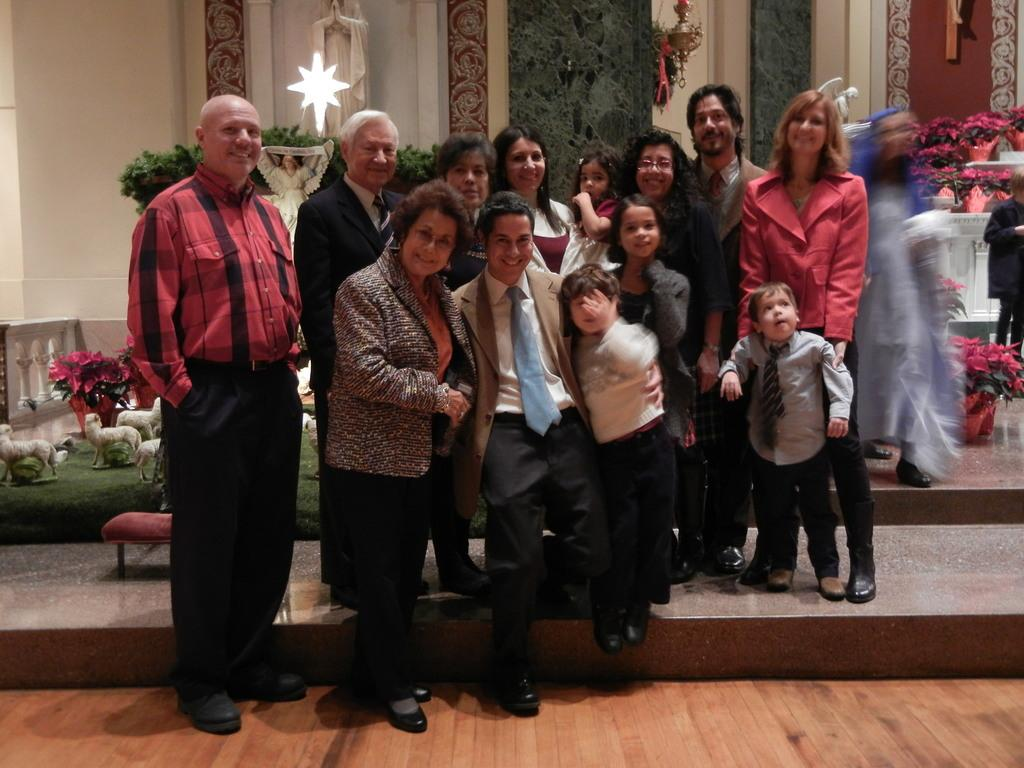What is happening in the image? There is a group of people standing in the image. What can be seen in the background of the image? There are flower pots and a wall visible in the background of the image. How many spiders are crawling on the wall in the image? There are no spiders visible in the image; only the wall and flower pots can be seen in the background. 